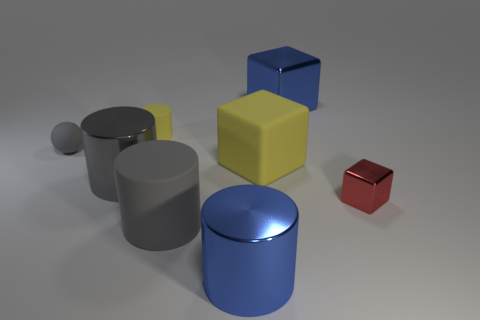Is the big blue cylinder made of the same material as the sphere?
Your answer should be compact. No. What is the color of the cube in front of the yellow rubber thing in front of the small gray sphere?
Give a very brief answer. Red. There is a yellow object that is the same shape as the gray metallic thing; what is its size?
Make the answer very short. Small. Does the tiny metal thing have the same color as the large matte block?
Make the answer very short. No. There is a metal cylinder to the left of the large blue thing in front of the small red metal thing; how many large blue metal cylinders are right of it?
Offer a very short reply. 1. Is the number of red objects greater than the number of brown cylinders?
Provide a succinct answer. Yes. How many big gray shiny cylinders are there?
Your answer should be compact. 1. What shape is the big blue object that is on the left side of the big block behind the big block that is on the left side of the big blue metal block?
Your answer should be compact. Cylinder. Is the number of tiny red metallic things that are in front of the small gray sphere less than the number of big yellow rubber objects to the right of the red object?
Provide a short and direct response. No. There is a large blue object that is on the right side of the yellow matte cube; is its shape the same as the gray object on the right side of the tiny yellow object?
Your answer should be very brief. No. 